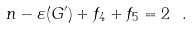Convert formula to latex. <formula><loc_0><loc_0><loc_500><loc_500>n - \varepsilon ( G ^ { \prime } ) + f _ { 4 } + f _ { 5 } = 2 \ .</formula> 